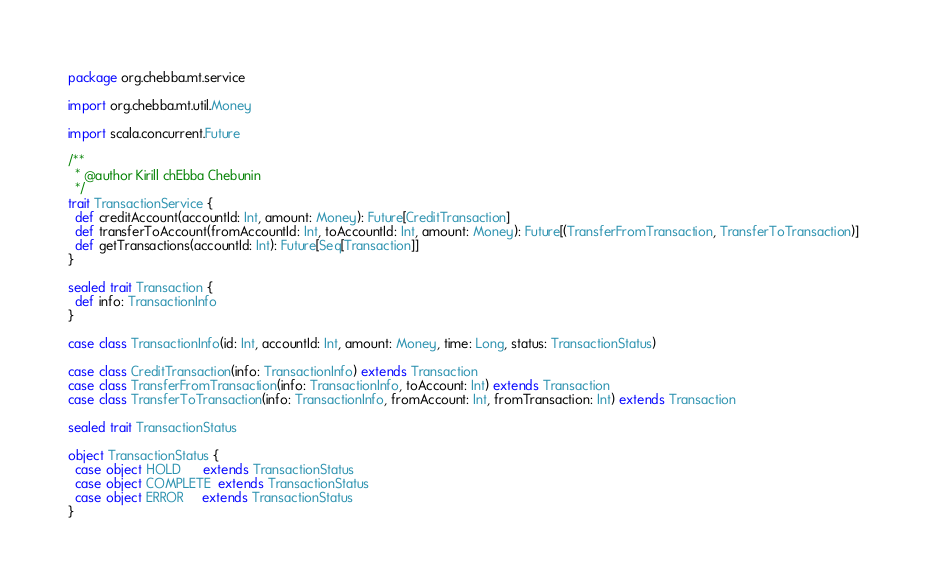Convert code to text. <code><loc_0><loc_0><loc_500><loc_500><_Scala_>package org.chebba.mt.service

import org.chebba.mt.util.Money

import scala.concurrent.Future

/**
  * @author Kirill chEbba Chebunin
  */
trait TransactionService {
  def creditAccount(accountId: Int, amount: Money): Future[CreditTransaction]
  def transferToAccount(fromAccountId: Int, toAccountId: Int, amount: Money): Future[(TransferFromTransaction, TransferToTransaction)]
  def getTransactions(accountId: Int): Future[Seq[Transaction]]
}

sealed trait Transaction {
  def info: TransactionInfo
}

case class TransactionInfo(id: Int, accountId: Int, amount: Money, time: Long, status: TransactionStatus)

case class CreditTransaction(info: TransactionInfo) extends Transaction
case class TransferFromTransaction(info: TransactionInfo, toAccount: Int) extends Transaction
case class TransferToTransaction(info: TransactionInfo, fromAccount: Int, fromTransaction: Int) extends Transaction

sealed trait TransactionStatus

object TransactionStatus {
  case object HOLD      extends TransactionStatus
  case object COMPLETE  extends TransactionStatus
  case object ERROR     extends TransactionStatus
}
</code> 